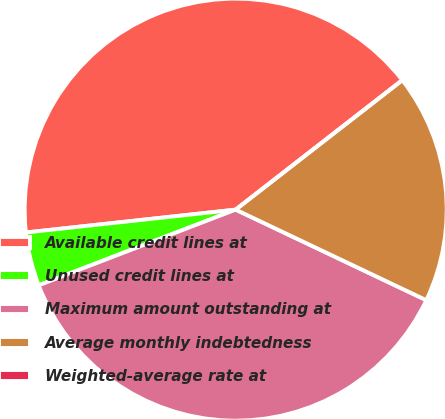Convert chart. <chart><loc_0><loc_0><loc_500><loc_500><pie_chart><fcel>Available credit lines at<fcel>Unused credit lines at<fcel>Maximum amount outstanding at<fcel>Average monthly indebtedness<fcel>Weighted-average rate at<nl><fcel>41.21%<fcel>4.11%<fcel>37.1%<fcel>17.57%<fcel>0.0%<nl></chart> 